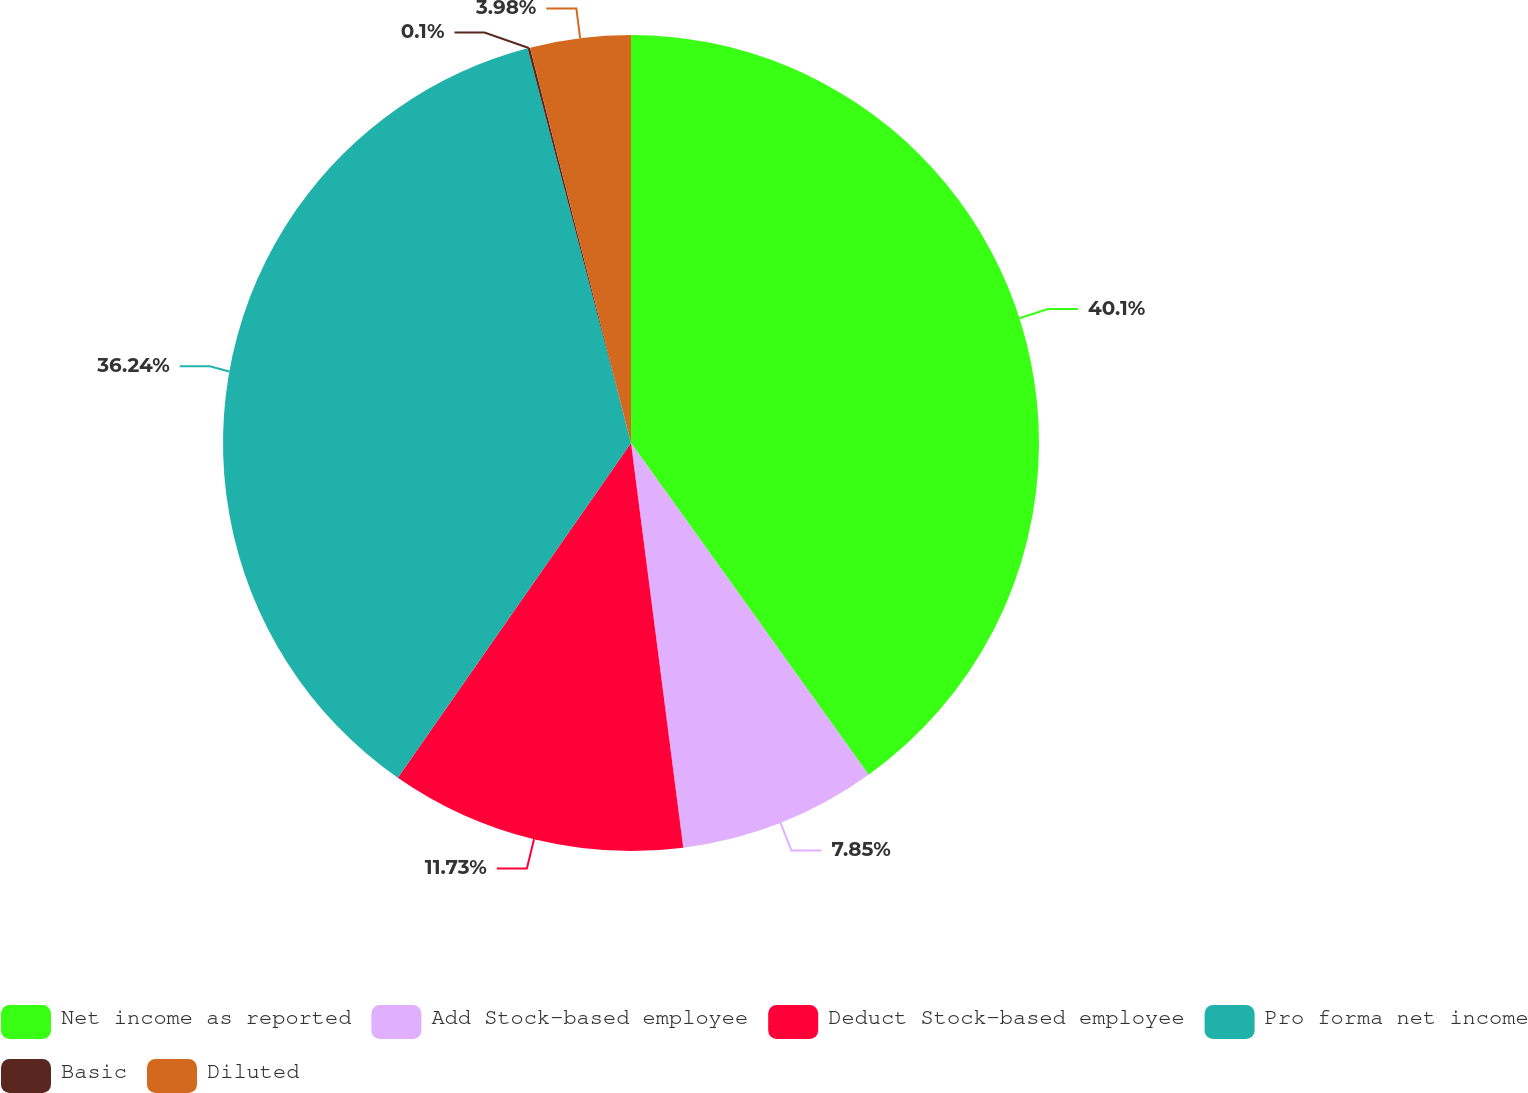Convert chart to OTSL. <chart><loc_0><loc_0><loc_500><loc_500><pie_chart><fcel>Net income as reported<fcel>Add Stock-based employee<fcel>Deduct Stock-based employee<fcel>Pro forma net income<fcel>Basic<fcel>Diluted<nl><fcel>40.11%<fcel>7.85%<fcel>11.73%<fcel>36.24%<fcel>0.1%<fcel>3.98%<nl></chart> 